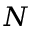Convert formula to latex. <formula><loc_0><loc_0><loc_500><loc_500>N</formula> 